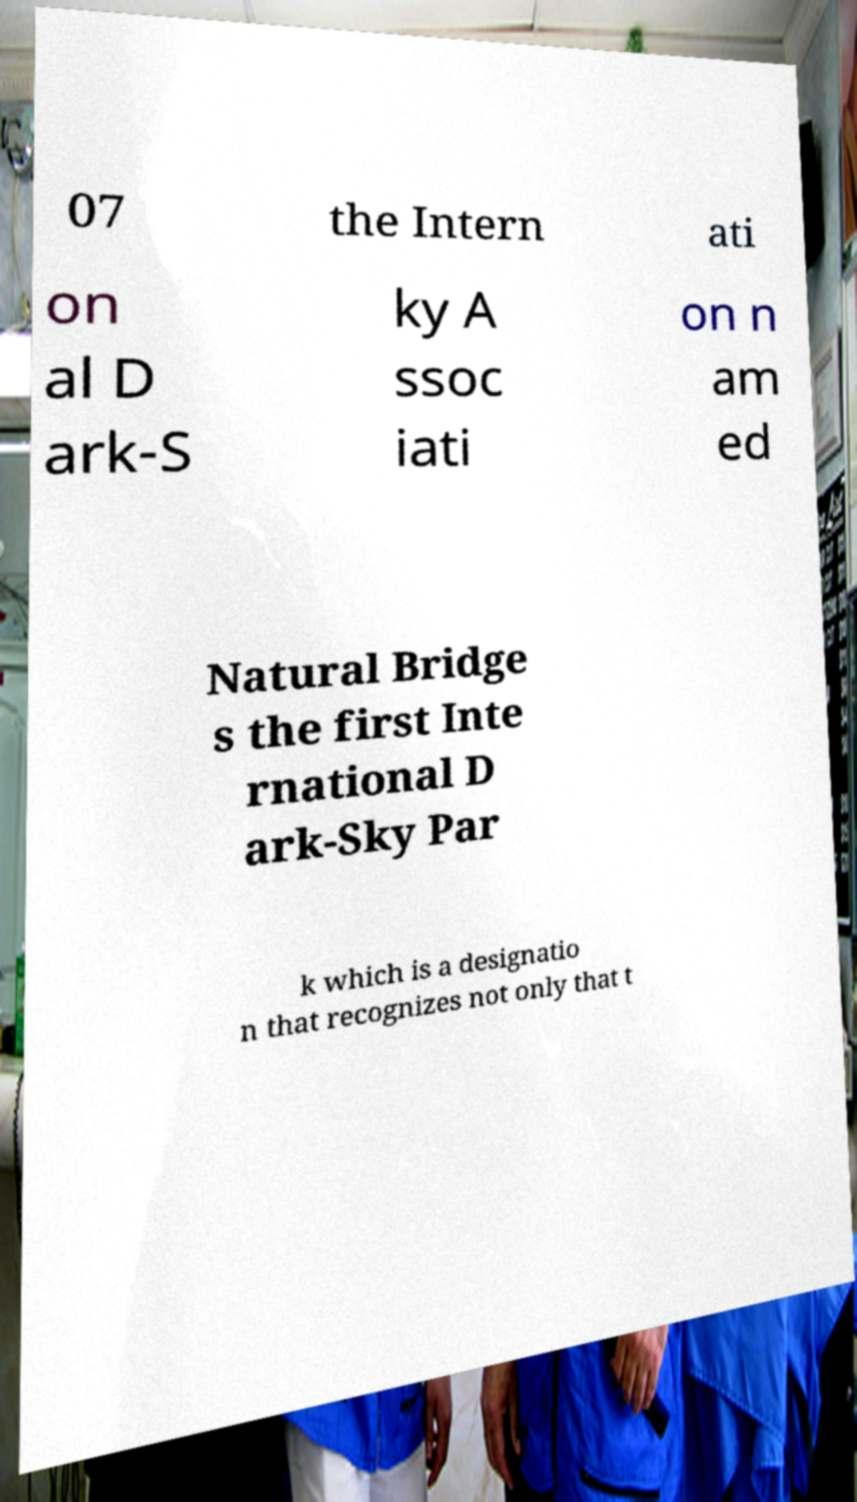Could you extract and type out the text from this image? 07 the Intern ati on al D ark-S ky A ssoc iati on n am ed Natural Bridge s the first Inte rnational D ark-Sky Par k which is a designatio n that recognizes not only that t 